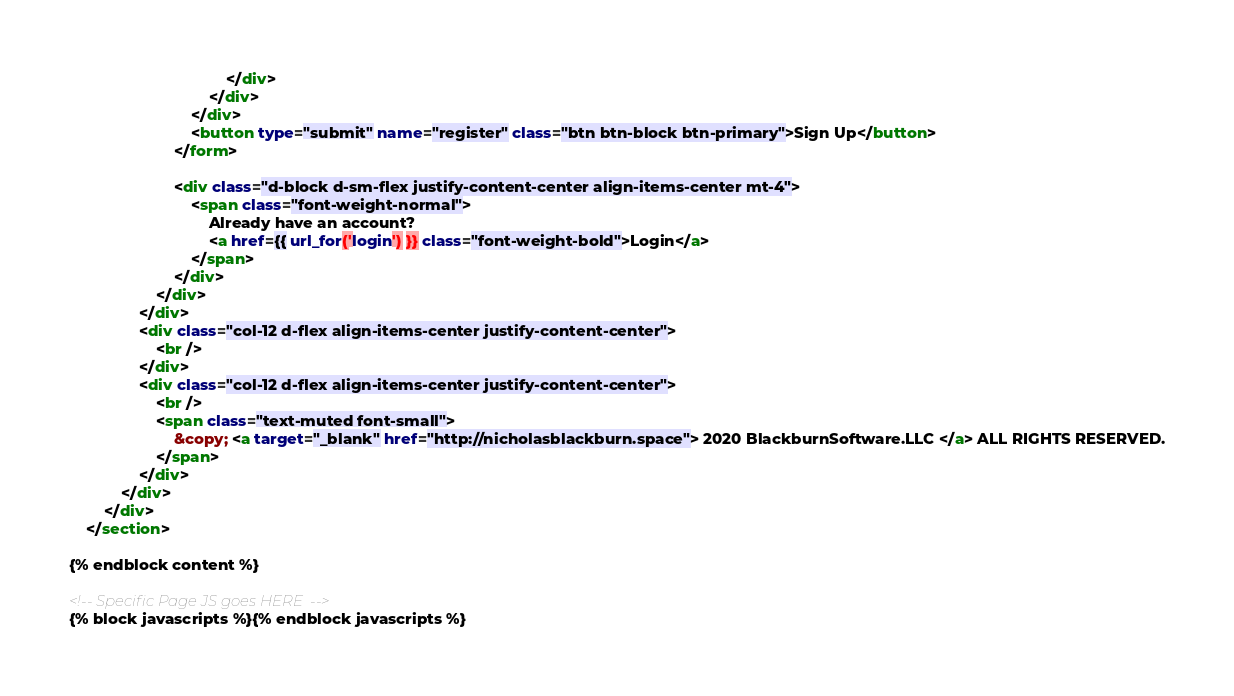Convert code to text. <code><loc_0><loc_0><loc_500><loc_500><_HTML_>                                    </div>
                                </div>
                            </div>
                            <button type="submit" name="register" class="btn btn-block btn-primary">Sign Up</button>
                        </form>

                        <div class="d-block d-sm-flex justify-content-center align-items-center mt-4">
                            <span class="font-weight-normal">
                                Already have an account?
                                <a href={{ url_for('login') }} class="font-weight-bold">Login</a>
                            </span>
                        </div>
                    </div>
                </div>
                <div class="col-12 d-flex align-items-center justify-content-center">
                    <br />    
                </div>
                <div class="col-12 d-flex align-items-center justify-content-center">
                    <br />    
                    <span class="text-muted font-small"> 
                        &copy; <a target="_blank" href="http://nicholasblackburn.space"> 2020 BlackburnSoftware.LLC </a> ALL RIGHTS RESERVED.
                    </span>
                </div>
            </div>
        </div>
    </section>

{% endblock content %}

<!-- Specific Page JS goes HERE  -->
{% block javascripts %}{% endblock javascripts %}
</code> 